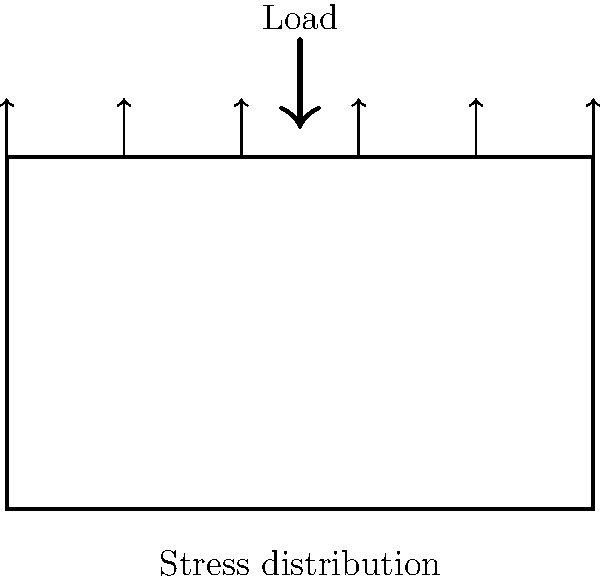In a classic 90s boombox-shaped speaker cabinet under vertical load, which stress distribution pattern is most likely to occur along the top surface?
a) Uniform stress distribution
b) Parabolic stress distribution with maximum at the center
c) Linear stress distribution increasing from edges to center
d) Stress concentration at the edges To determine the stress distribution in a boombox-shaped speaker cabinet under load, we need to consider the following steps:

1. Geometry: The boombox shape can be approximated as a rectangular box, which is similar to a simple beam.

2. Loading condition: The vertical load applied at the top of the cabinet is analogous to a distributed load on a beam.

3. Beam theory: For a simply supported beam under a uniformly distributed load, the bending moment distribution is parabolic, with the maximum at the center.

4. Stress-moment relationship: The normal stress due to bending is directly proportional to the bending moment. Therefore, the stress distribution will follow a similar pattern to the moment distribution.

5. Saint-Venant's principle: The stress distribution near the edges might be slightly different due to local effects, but the overall distribution will be dominated by the global bending behavior.

6. Material considerations: Assuming the cabinet is made of a homogeneous, isotropic material (like plastic or wood), the stress will be proportional to the strain.

Given these factors, the stress distribution along the top surface of the boombox-shaped cabinet will most likely be parabolic, with the maximum stress occurring at the center. This corresponds to option b) in the given choices.

This stress distribution is reminiscent of the way classic hip-hop beats build up to a crescendo in the middle of a track, much like the stress peaks at the center of our boombox.
Answer: b) Parabolic stress distribution with maximum at the center 